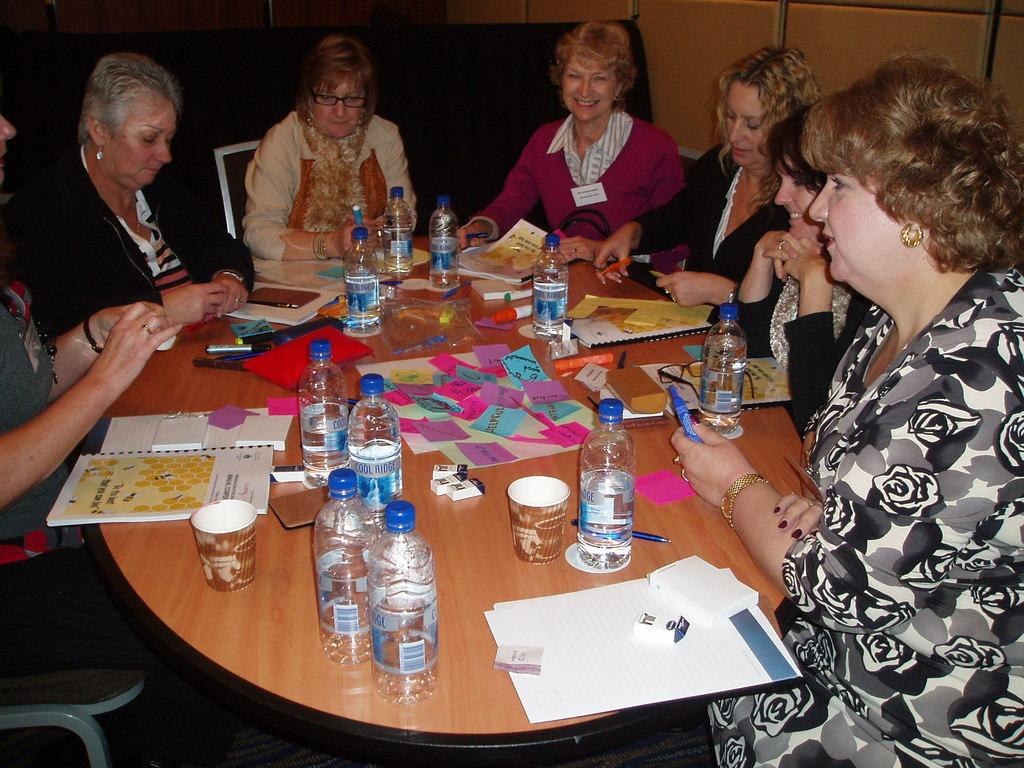What is the main subject of the image? The main subject of the image is a group of women. What are the women doing in the image? The women are sitting on chairs in the image. What is located in front of the women? There is a table in front of the women. What can be found on the table? Bottles of water are present on the table. What else is visible in the image besides the women and the table? There are books and papers in the image. What is the general mood or expression of the women in the image? The women are smiling in the image. What color is the branch that the women are holding in the image? There is no branch present in the image. 